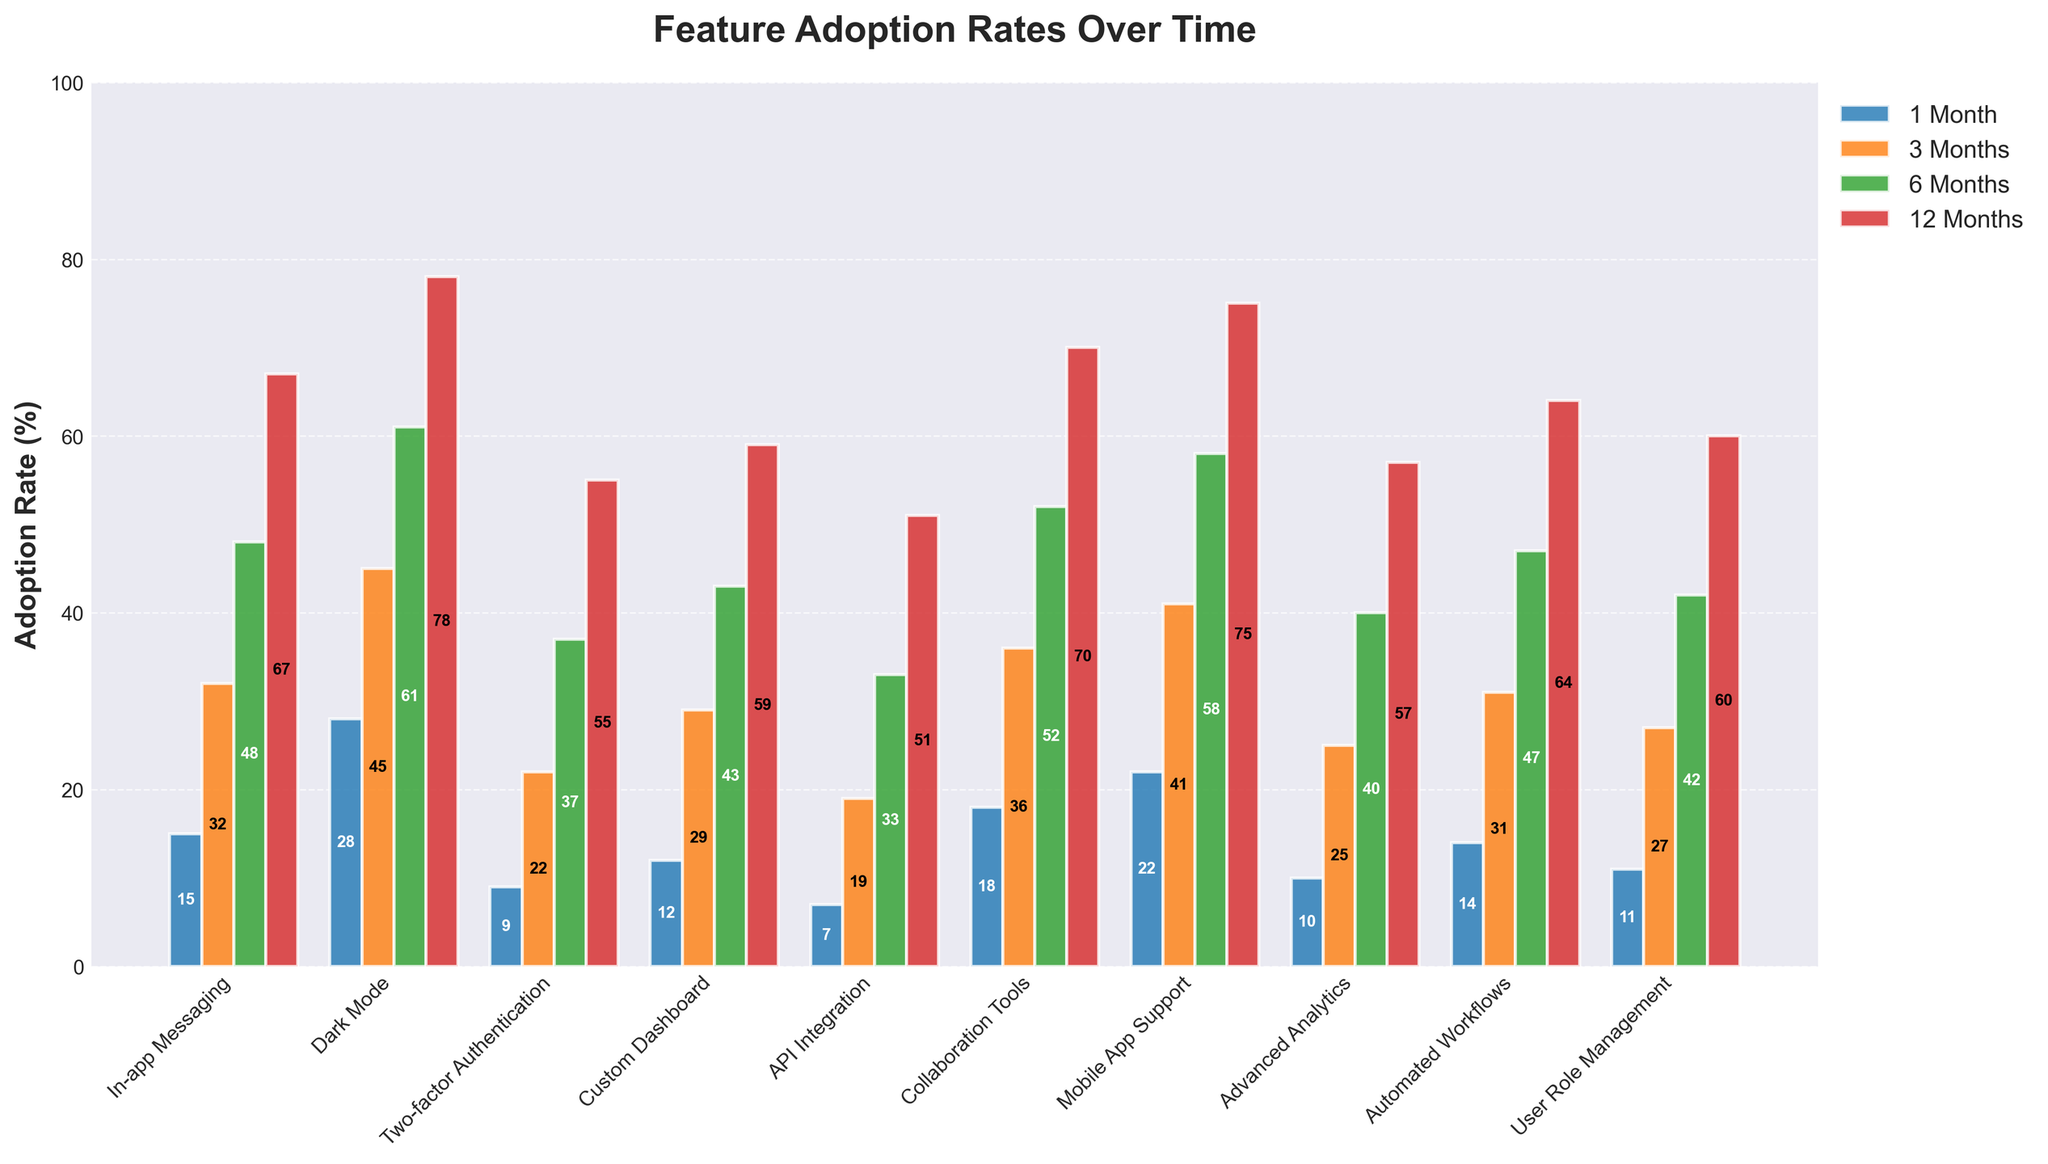Which feature has the highest adoption rate at 12 months? Look for the bar with the maximum height at the 12 Months mark. Collaboration Tools has the highest bar.
Answer: Collaboration Tools How does the adoption rate of Dark Mode at 6 months compare to that of Custom Dashboard at the same time? Compare the heights of the bars for Dark Mode and Custom Dashboard at 6 Months. Dark Mode's bar is higher than Custom Dashboard.
Answer: Dark Mode is higher What is the average adoption rate of Mobile App Support over the 4 time points? Summarize the adoption rates at 1, 3, 6, and 12 months: (22 + 41 + 58 + 75)/4 = 49%.
Answer: 49% Which feature shows the lowest adoption rate at 1 month and what is the rate? Look for the shortest bar at the 1 Month mark. API Integration has the lowest bar.
Answer: API Integration at 7% What is the difference in adoption rates between In-app Messaging and Automated Workflows at 3 months? Find the heights of the bars for both at 3 Months and subtract: 32 - 31 = 1%.
Answer: 1% Among the features, which one shows the second fastest growth in adoption from 1 month to 6 months? Calculate differences between the adoption rates at 1 Month and 6 Months for each feature and find the second largest. Dark Mode grows from 28% to 61%, which is a change of 33%. Second largest is Mobile App Support (36%).
Answer: Mobile App Support Which feature sees an equal or higher adoption rate than User Role Management at 1 month? Look at the height of User Role Management at 1 Month (11%) and see which other bars are as tall or taller. Several features, including Dark Mode, Collaboration Tools, and Mobile App Support, meet this criteria.
Answer: Dark Mode, Collaboration Tools, Mobile App Support What is the total adoption rate for Advanced Analytics and API Integration at 12 months combined? Add the adoption rates at 12 Months for both: 57 + 51 = 108%.
Answer: 108% Which feature shows the smallest growth in adoption rate between 6 months and 12 months? Calculate the differences between 6 Months and 12 Months for all features and find the smallest. Two-factor Authentication grows from 37% to 55%, a change of 18%.
Answer: Two-factor Authentication 